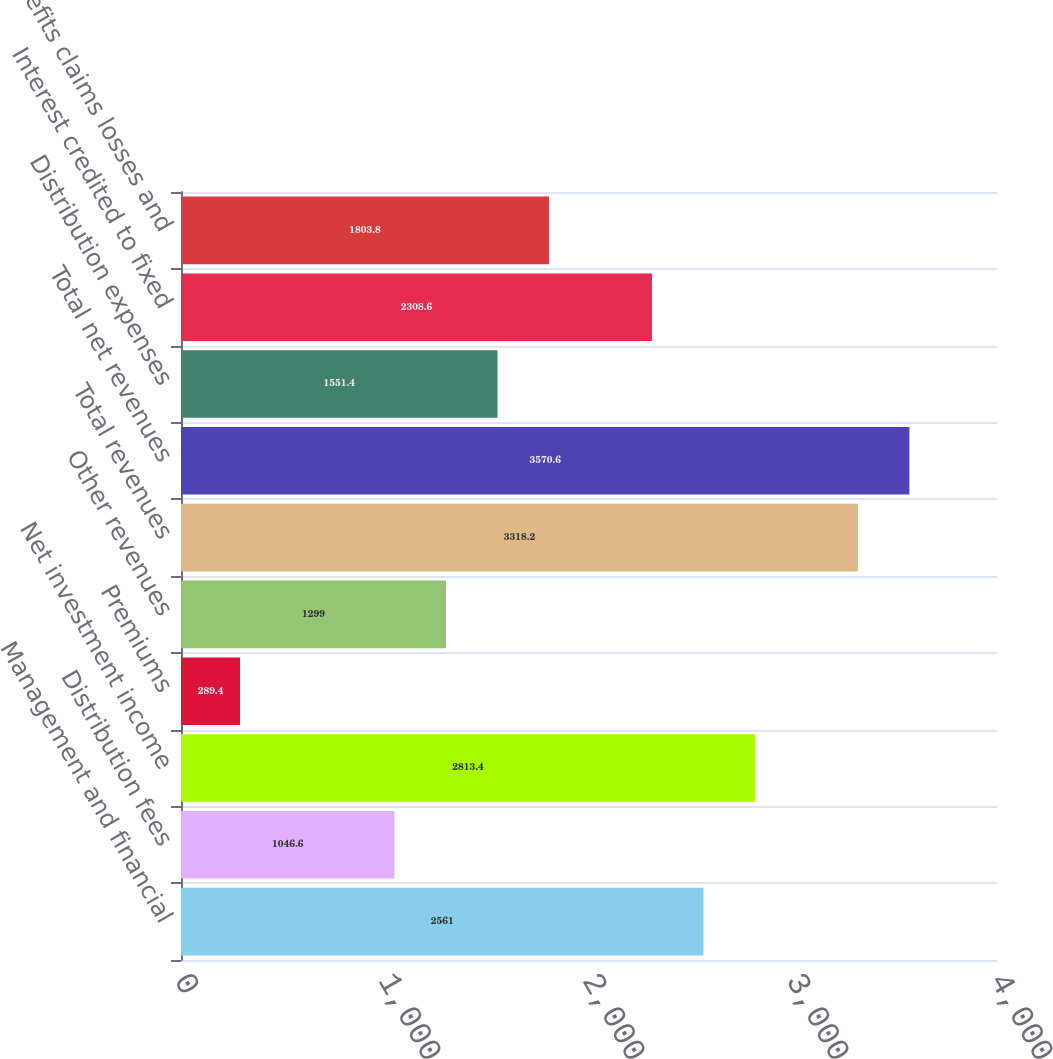<chart> <loc_0><loc_0><loc_500><loc_500><bar_chart><fcel>Management and financial<fcel>Distribution fees<fcel>Net investment income<fcel>Premiums<fcel>Other revenues<fcel>Total revenues<fcel>Total net revenues<fcel>Distribution expenses<fcel>Interest credited to fixed<fcel>Benefits claims losses and<nl><fcel>2561<fcel>1046.6<fcel>2813.4<fcel>289.4<fcel>1299<fcel>3318.2<fcel>3570.6<fcel>1551.4<fcel>2308.6<fcel>1803.8<nl></chart> 